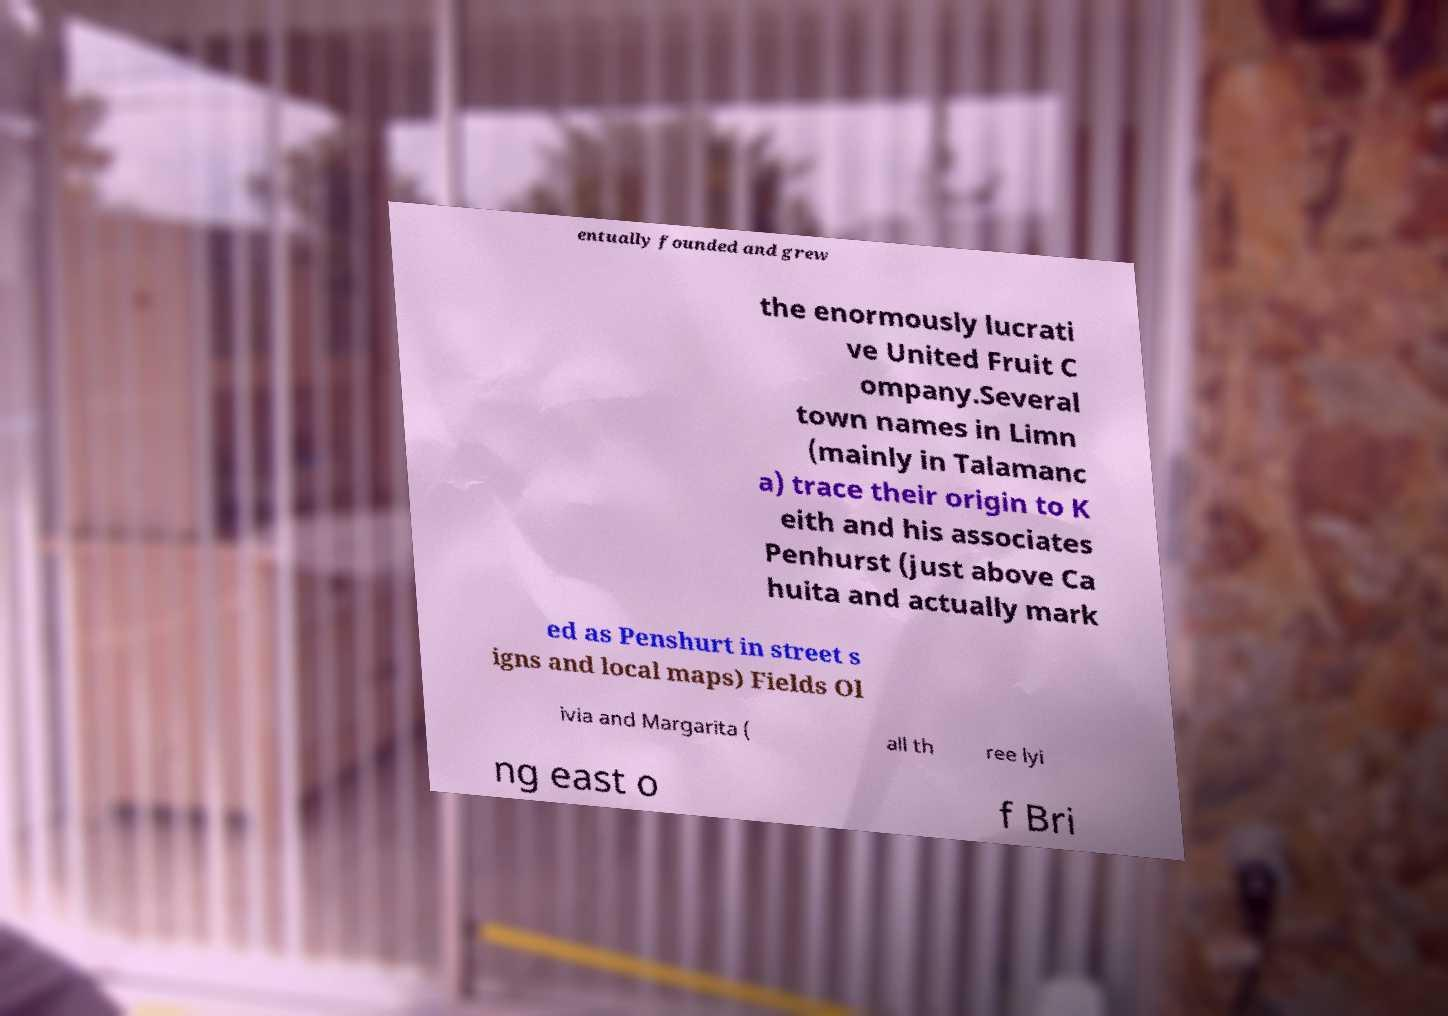Can you accurately transcribe the text from the provided image for me? entually founded and grew the enormously lucrati ve United Fruit C ompany.Several town names in Limn (mainly in Talamanc a) trace their origin to K eith and his associates Penhurst (just above Ca huita and actually mark ed as Penshurt in street s igns and local maps) Fields Ol ivia and Margarita ( all th ree lyi ng east o f Bri 